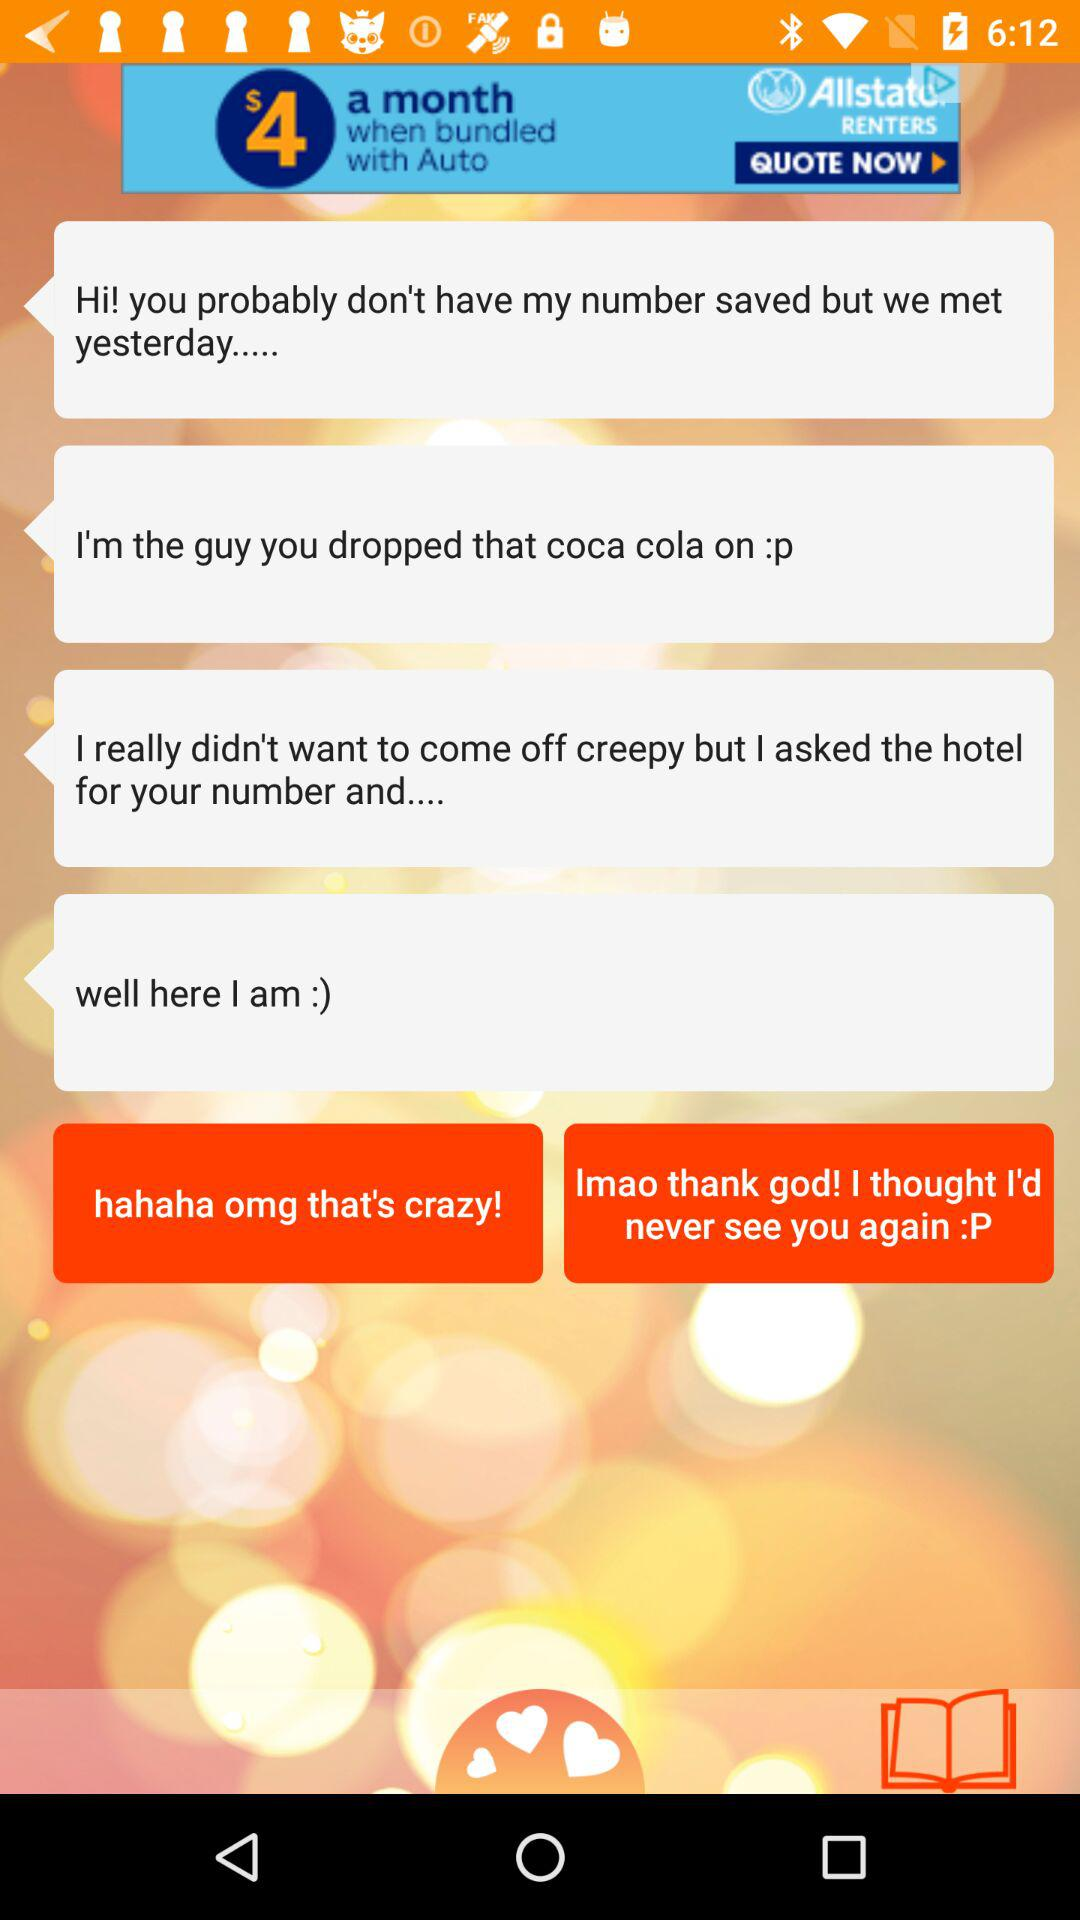How many more hearts are there than books?
Answer the question using a single word or phrase. 2 